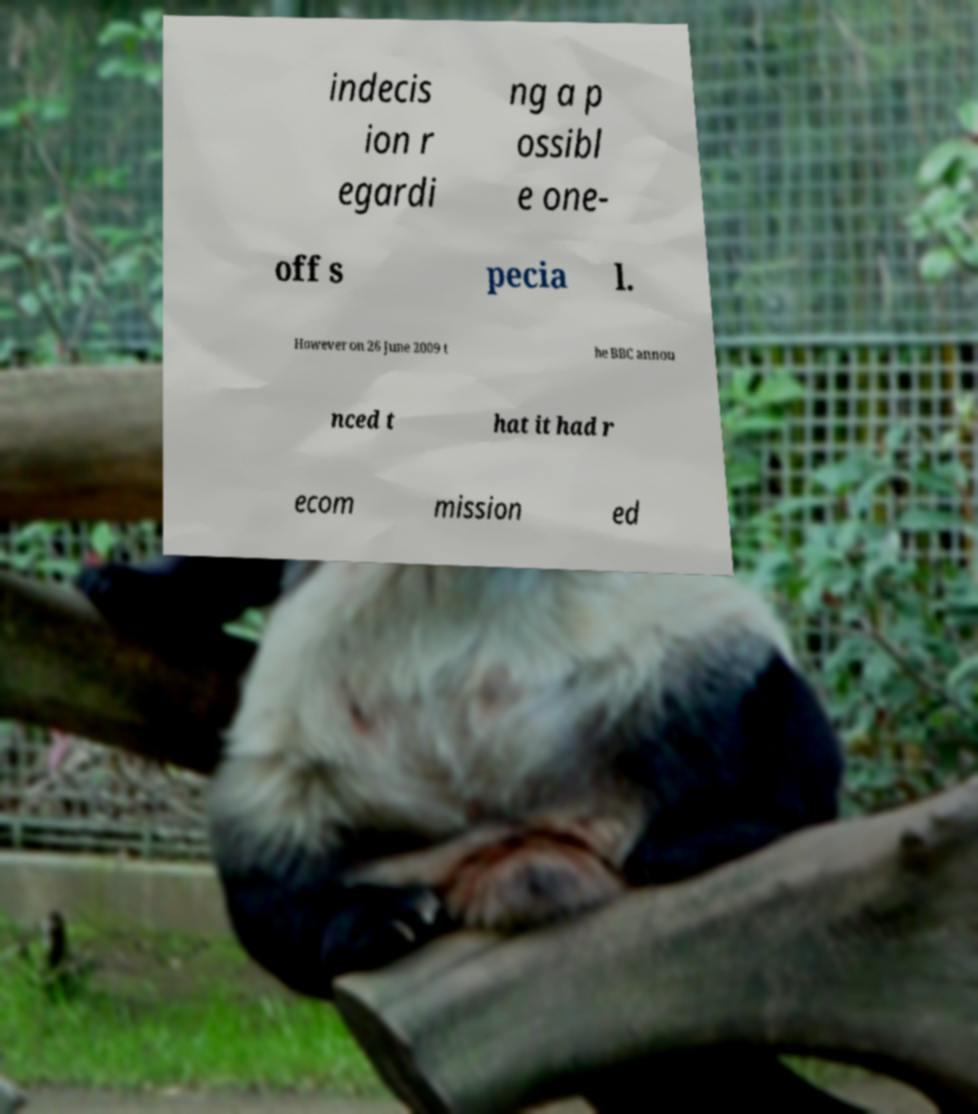I need the written content from this picture converted into text. Can you do that? indecis ion r egardi ng a p ossibl e one- off s pecia l. However on 26 June 2009 t he BBC annou nced t hat it had r ecom mission ed 